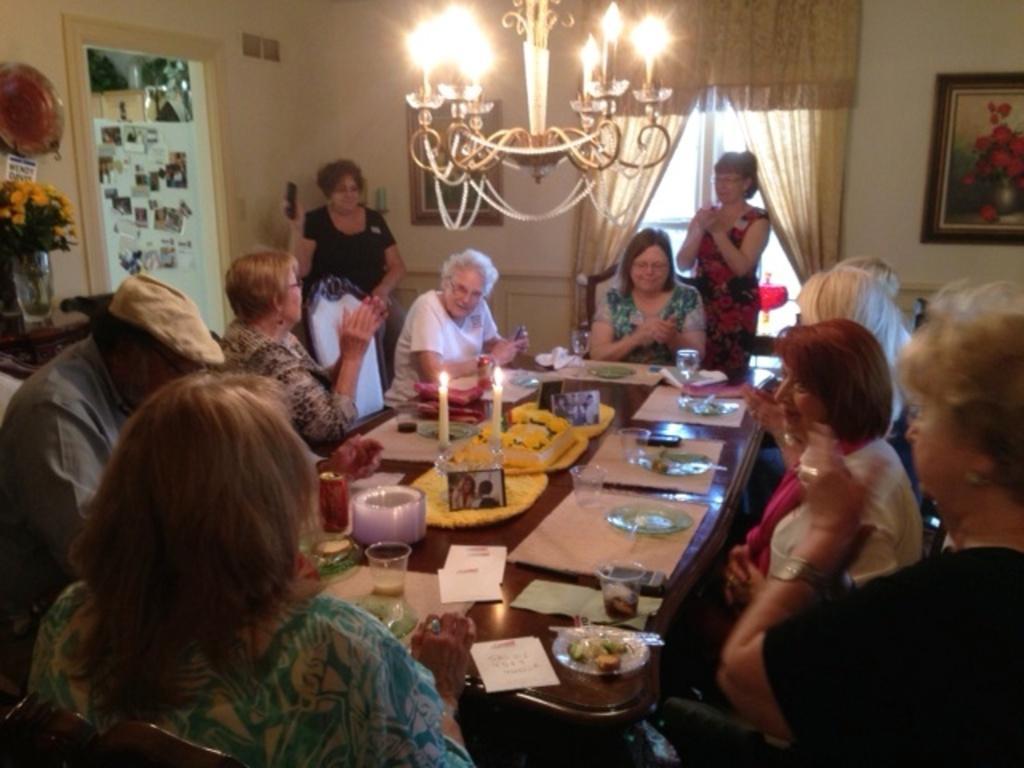Could you give a brief overview of what you see in this image? This picture shows a group of people seated on the chairs and we see few glasses and plates on the table and and we see two woman standing on the back and we see curtains to the window and a photo frame on the wall 